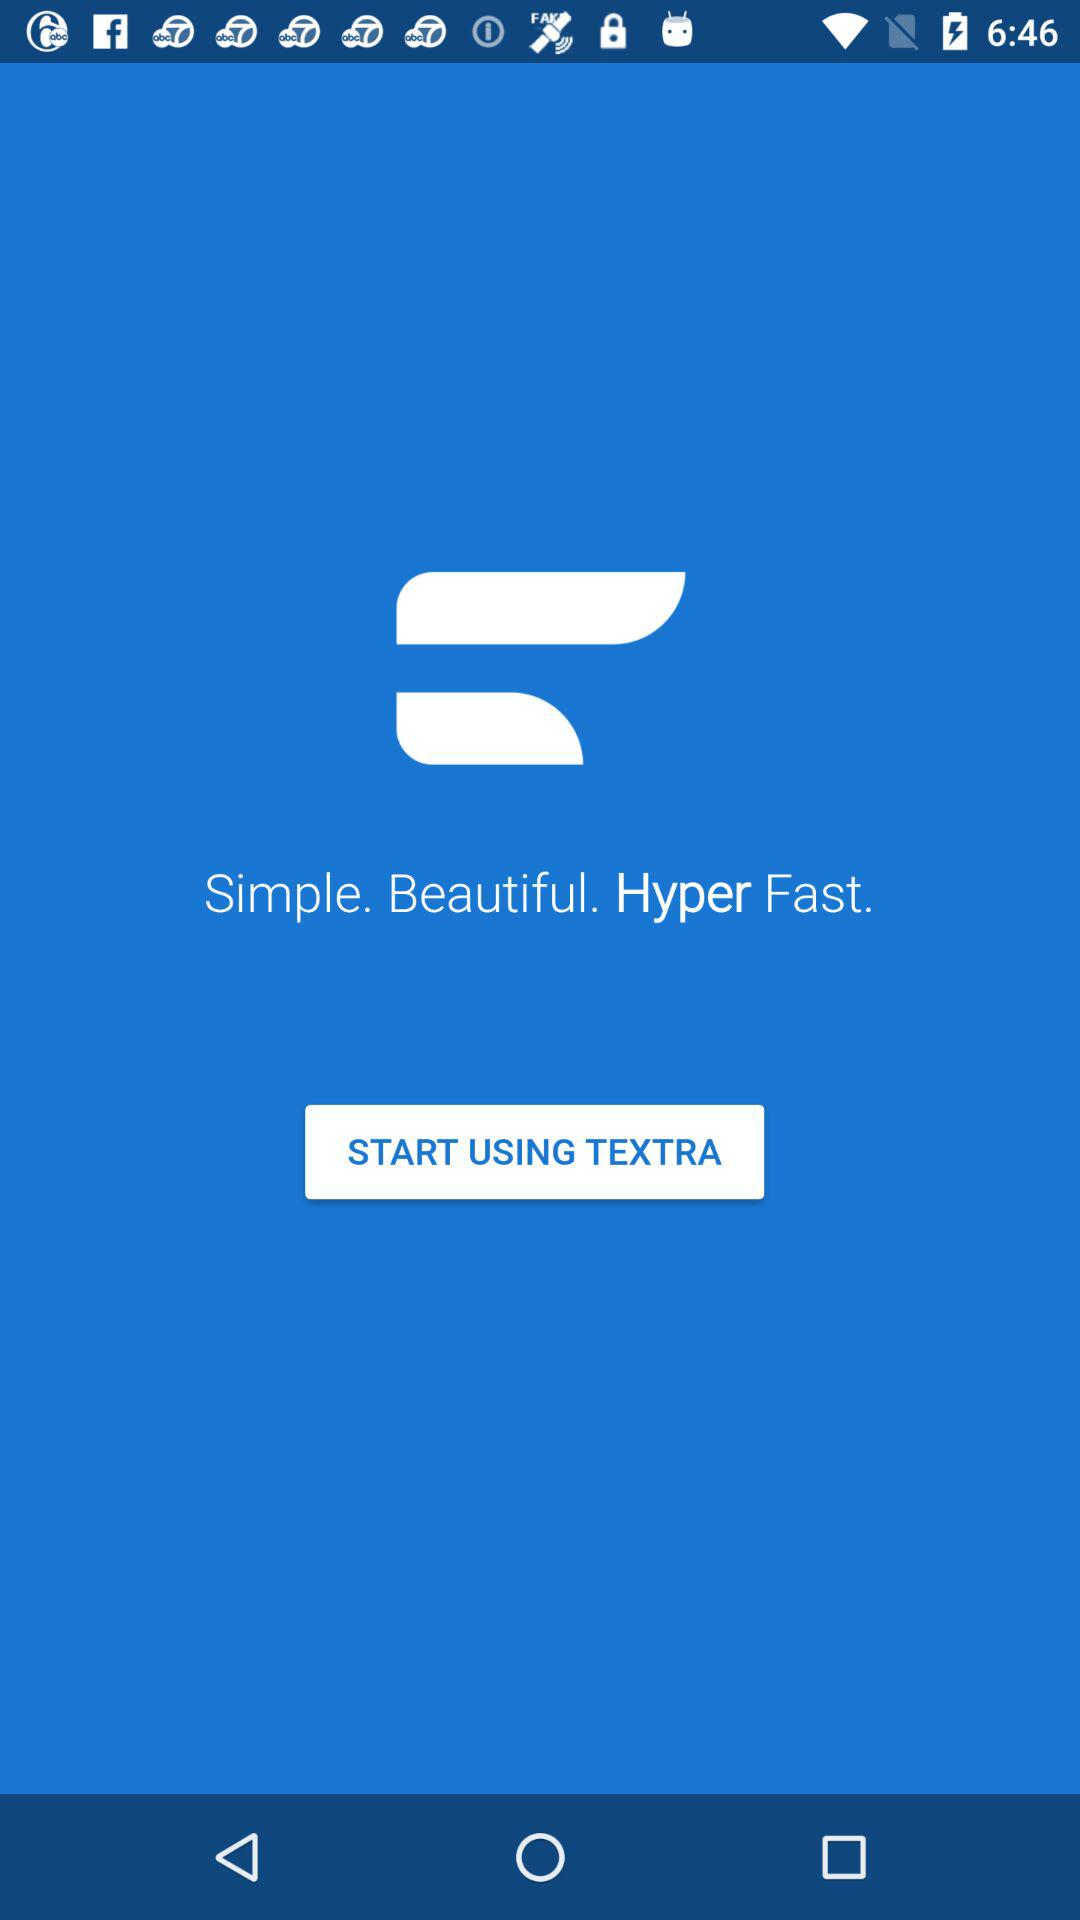What is the name of the app? The name of the app is "TEXTRA". 